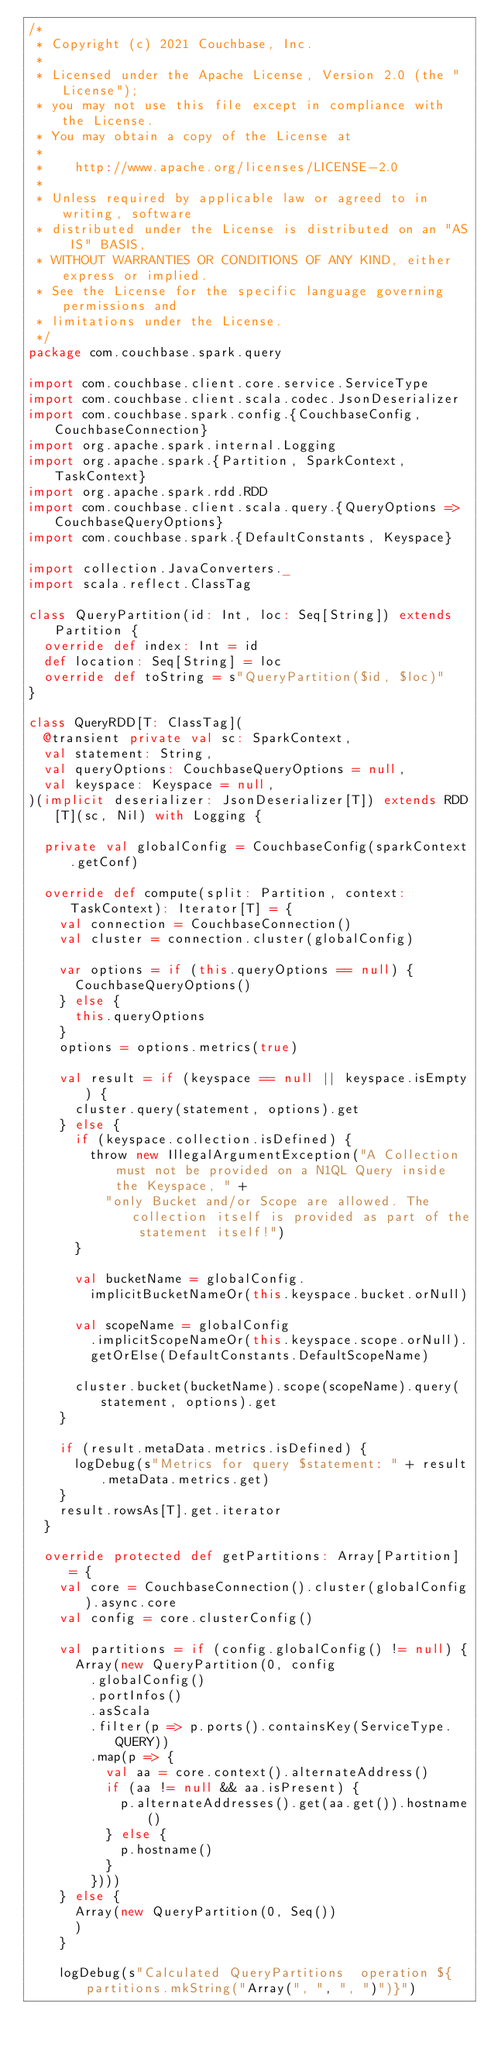Convert code to text. <code><loc_0><loc_0><loc_500><loc_500><_Scala_>/*
 * Copyright (c) 2021 Couchbase, Inc.
 *
 * Licensed under the Apache License, Version 2.0 (the "License");
 * you may not use this file except in compliance with the License.
 * You may obtain a copy of the License at
 *
 *    http://www.apache.org/licenses/LICENSE-2.0
 *
 * Unless required by applicable law or agreed to in writing, software
 * distributed under the License is distributed on an "AS IS" BASIS,
 * WITHOUT WARRANTIES OR CONDITIONS OF ANY KIND, either express or implied.
 * See the License for the specific language governing permissions and
 * limitations under the License.
 */
package com.couchbase.spark.query

import com.couchbase.client.core.service.ServiceType
import com.couchbase.client.scala.codec.JsonDeserializer
import com.couchbase.spark.config.{CouchbaseConfig, CouchbaseConnection}
import org.apache.spark.internal.Logging
import org.apache.spark.{Partition, SparkContext, TaskContext}
import org.apache.spark.rdd.RDD
import com.couchbase.client.scala.query.{QueryOptions => CouchbaseQueryOptions}
import com.couchbase.spark.{DefaultConstants, Keyspace}

import collection.JavaConverters._
import scala.reflect.ClassTag

class QueryPartition(id: Int, loc: Seq[String]) extends Partition {
  override def index: Int = id
  def location: Seq[String] = loc
  override def toString = s"QueryPartition($id, $loc)"
}

class QueryRDD[T: ClassTag](
  @transient private val sc: SparkContext,
  val statement: String,
  val queryOptions: CouchbaseQueryOptions = null,
  val keyspace: Keyspace = null,
)(implicit deserializer: JsonDeserializer[T]) extends RDD[T](sc, Nil) with Logging {

  private val globalConfig = CouchbaseConfig(sparkContext.getConf)

  override def compute(split: Partition, context: TaskContext): Iterator[T] = {
    val connection = CouchbaseConnection()
    val cluster = connection.cluster(globalConfig)

    var options = if (this.queryOptions == null) {
      CouchbaseQueryOptions()
    } else {
      this.queryOptions
    }
    options = options.metrics(true)

    val result = if (keyspace == null || keyspace.isEmpty) {
      cluster.query(statement, options).get
    } else {
      if (keyspace.collection.isDefined) {
        throw new IllegalArgumentException("A Collection must not be provided on a N1QL Query inside the Keyspace, " +
          "only Bucket and/or Scope are allowed. The collection itself is provided as part of the statement itself!")
      }

      val bucketName = globalConfig.
        implicitBucketNameOr(this.keyspace.bucket.orNull)

      val scopeName = globalConfig
        .implicitScopeNameOr(this.keyspace.scope.orNull).
        getOrElse(DefaultConstants.DefaultScopeName)

      cluster.bucket(bucketName).scope(scopeName).query(statement, options).get
    }

    if (result.metaData.metrics.isDefined) {
      logDebug(s"Metrics for query $statement: " + result.metaData.metrics.get)
    }
    result.rowsAs[T].get.iterator
  }

  override protected def getPartitions: Array[Partition] = {
    val core = CouchbaseConnection().cluster(globalConfig).async.core
    val config = core.clusterConfig()

    val partitions = if (config.globalConfig() != null) {
      Array(new QueryPartition(0, config
        .globalConfig()
        .portInfos()
        .asScala
        .filter(p => p.ports().containsKey(ServiceType.QUERY))
        .map(p => {
          val aa = core.context().alternateAddress()
          if (aa != null && aa.isPresent) {
            p.alternateAddresses().get(aa.get()).hostname()
          } else {
            p.hostname()
          }
        })))
    } else {
      Array(new QueryPartition(0, Seq())
      )
    }

    logDebug(s"Calculated QueryPartitions  operation ${partitions.mkString("Array(", ", ", ")")}")
</code> 